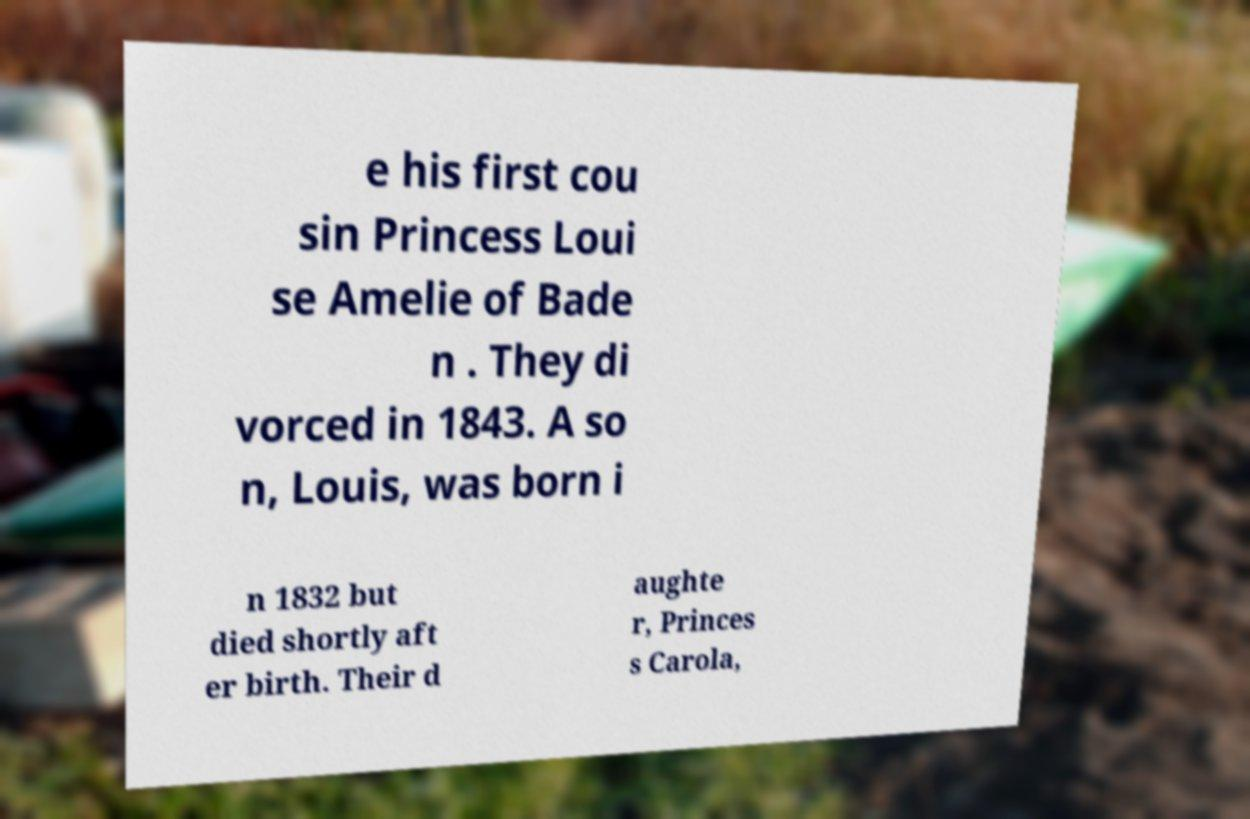What messages or text are displayed in this image? I need them in a readable, typed format. e his first cou sin Princess Loui se Amelie of Bade n . They di vorced in 1843. A so n, Louis, was born i n 1832 but died shortly aft er birth. Their d aughte r, Princes s Carola, 